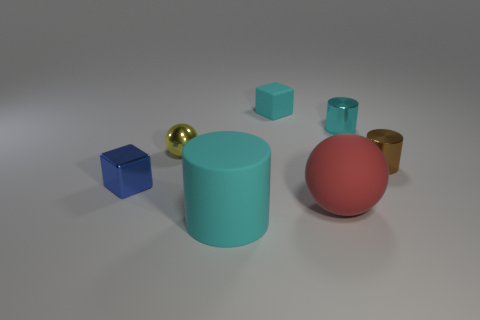What color is the big matte cylinder?
Keep it short and to the point. Cyan. What number of things are either blue metal blocks or cyan rubber blocks?
Offer a very short reply. 2. There is a brown cylinder that is the same size as the matte cube; what is its material?
Make the answer very short. Metal. What is the size of the cyan cylinder that is behind the small yellow metallic thing?
Your answer should be very brief. Small. What is the large cyan object made of?
Provide a short and direct response. Rubber. How many things are either rubber objects on the right side of the cyan block or cylinders that are behind the yellow metal sphere?
Provide a short and direct response. 2. What number of other things are there of the same color as the big cylinder?
Keep it short and to the point. 2. There is a cyan shiny thing; is its shape the same as the cyan rubber thing that is in front of the small brown metal thing?
Ensure brevity in your answer.  Yes. Are there fewer big cyan rubber cylinders in front of the small blue metal cube than small metallic objects that are to the left of the cyan shiny cylinder?
Provide a short and direct response. Yes. There is a brown object that is the same shape as the large cyan object; what is it made of?
Your answer should be very brief. Metal. 